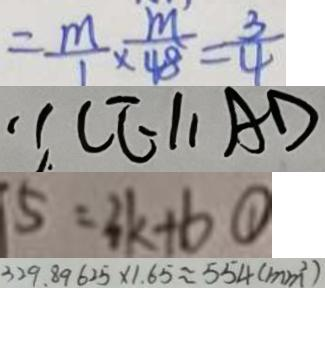Convert formula to latex. <formula><loc_0><loc_0><loc_500><loc_500>= \frac { m } { 1 } \times \frac { m } { 4 8 } = \frac { 3 } { 4 } 
 \because C E / / A D 
 5 = 3 k + b \textcircled { 1 } 
 3 2 9 . 8 9 6 2 5 \times 1 . 6 5 \approx 5 5 4 ( m m ^ { 2 } )</formula> 